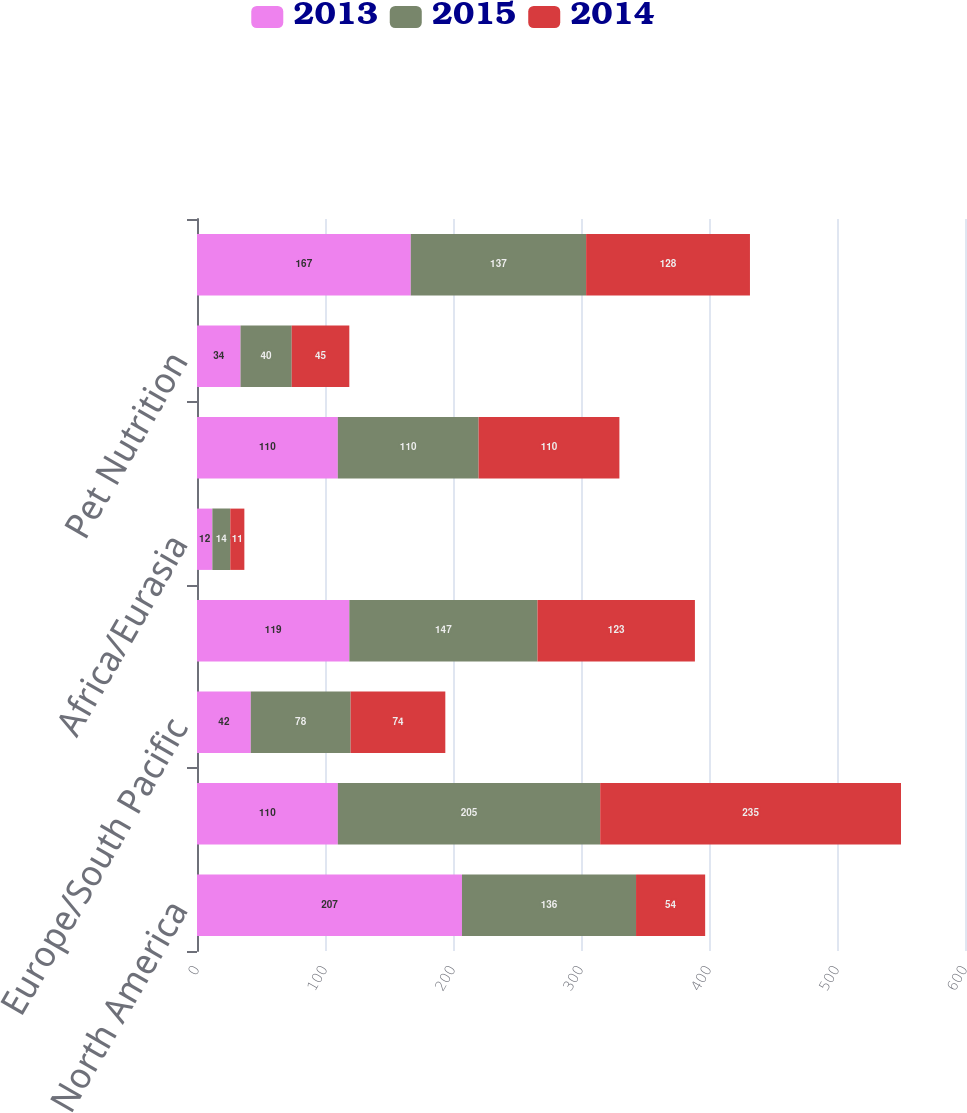<chart> <loc_0><loc_0><loc_500><loc_500><stacked_bar_chart><ecel><fcel>North America<fcel>Latin America<fcel>Europe/South Pacific<fcel>Asia<fcel>Africa/Eurasia<fcel>Total Oral Personal and Home<fcel>Pet Nutrition<fcel>Corporate<nl><fcel>2013<fcel>207<fcel>110<fcel>42<fcel>119<fcel>12<fcel>110<fcel>34<fcel>167<nl><fcel>2015<fcel>136<fcel>205<fcel>78<fcel>147<fcel>14<fcel>110<fcel>40<fcel>137<nl><fcel>2014<fcel>54<fcel>235<fcel>74<fcel>123<fcel>11<fcel>110<fcel>45<fcel>128<nl></chart> 